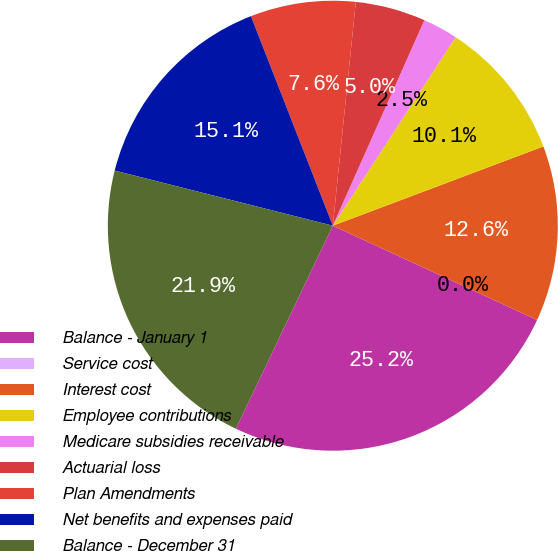<chart> <loc_0><loc_0><loc_500><loc_500><pie_chart><fcel>Balance - January 1<fcel>Service cost<fcel>Interest cost<fcel>Employee contributions<fcel>Medicare subsidies receivable<fcel>Actuarial loss<fcel>Plan Amendments<fcel>Net benefits and expenses paid<fcel>Balance - December 31<nl><fcel>25.21%<fcel>0.0%<fcel>12.61%<fcel>10.08%<fcel>2.52%<fcel>5.04%<fcel>7.56%<fcel>15.13%<fcel>21.85%<nl></chart> 